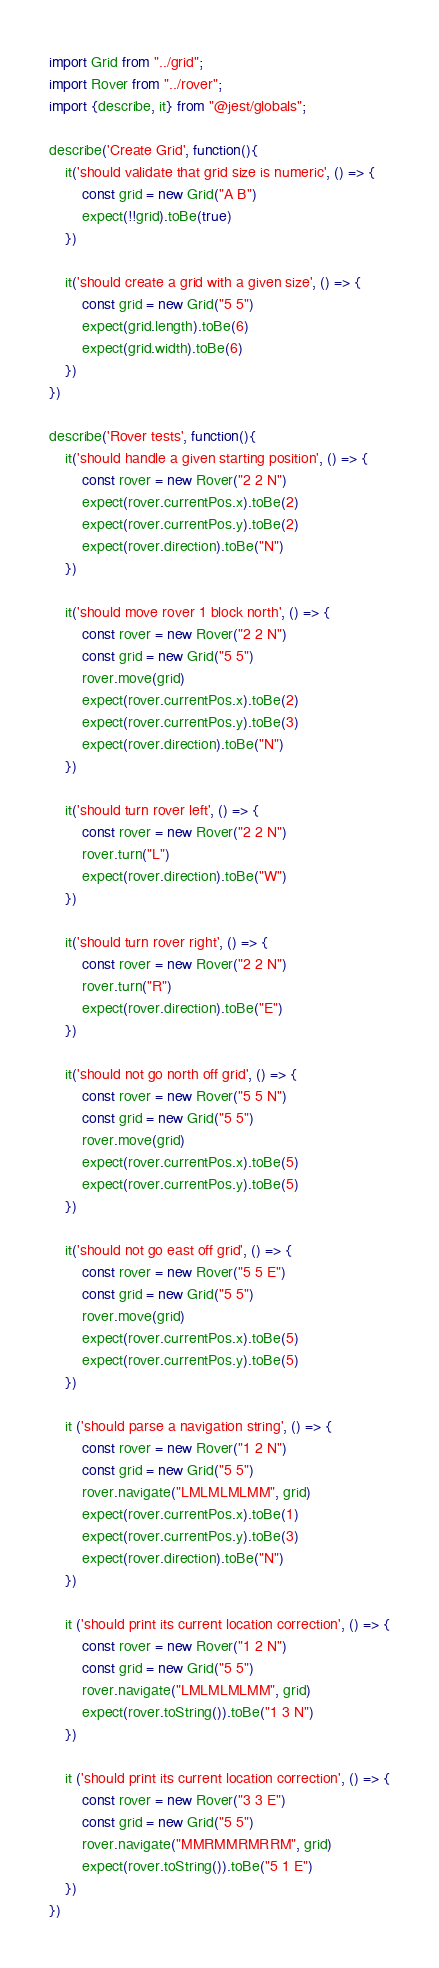<code> <loc_0><loc_0><loc_500><loc_500><_TypeScript_>import Grid from "../grid";
import Rover from "../rover";
import {describe, it} from "@jest/globals";

describe('Create Grid', function(){
    it('should validate that grid size is numeric', () => {
        const grid = new Grid("A B")
        expect(!!grid).toBe(true)
    })

    it('should create a grid with a given size', () => {
        const grid = new Grid("5 5")
        expect(grid.length).toBe(6)
        expect(grid.width).toBe(6)
    })
})

describe('Rover tests', function(){
    it('should handle a given starting position', () => {
        const rover = new Rover("2 2 N")
        expect(rover.currentPos.x).toBe(2)
        expect(rover.currentPos.y).toBe(2)
        expect(rover.direction).toBe("N")
    })

    it('should move rover 1 block north', () => {
        const rover = new Rover("2 2 N")
        const grid = new Grid("5 5")
        rover.move(grid)
        expect(rover.currentPos.x).toBe(2)
        expect(rover.currentPos.y).toBe(3)
        expect(rover.direction).toBe("N")
    })

    it('should turn rover left', () => {
        const rover = new Rover("2 2 N")
        rover.turn("L")
        expect(rover.direction).toBe("W")
    })

    it('should turn rover right', () => {
        const rover = new Rover("2 2 N")
        rover.turn("R")
        expect(rover.direction).toBe("E")
    })

    it('should not go north off grid', () => {
        const rover = new Rover("5 5 N")
        const grid = new Grid("5 5")
        rover.move(grid)
        expect(rover.currentPos.x).toBe(5)
        expect(rover.currentPos.y).toBe(5)
    })

    it('should not go east off grid', () => {
        const rover = new Rover("5 5 E")
        const grid = new Grid("5 5")
        rover.move(grid)
        expect(rover.currentPos.x).toBe(5)
        expect(rover.currentPos.y).toBe(5)
    })

    it ('should parse a navigation string', () => {
        const rover = new Rover("1 2 N")
        const grid = new Grid("5 5")
        rover.navigate("LMLMLMLMM", grid)
        expect(rover.currentPos.x).toBe(1)
        expect(rover.currentPos.y).toBe(3)
        expect(rover.direction).toBe("N")
    })

    it ('should print its current location correction', () => {
        const rover = new Rover("1 2 N")
        const grid = new Grid("5 5")
        rover.navigate("LMLMLMLMM", grid)
        expect(rover.toString()).toBe("1 3 N")
    })

    it ('should print its current location correction', () => {
        const rover = new Rover("3 3 E")
        const grid = new Grid("5 5")
        rover.navigate("MMRMMRMRRM", grid)
        expect(rover.toString()).toBe("5 1 E")
    })
})

</code> 